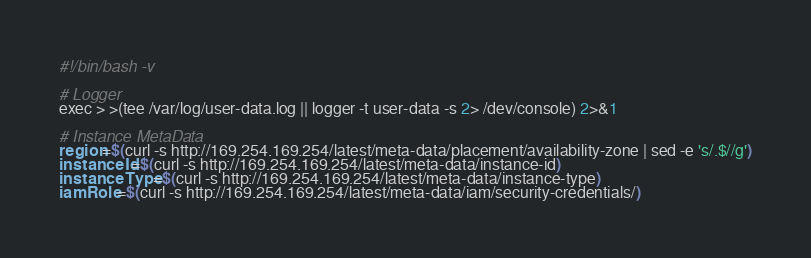Convert code to text. <code><loc_0><loc_0><loc_500><loc_500><_Bash_>#!/bin/bash -v

# Logger
exec > >(tee /var/log/user-data.log || logger -t user-data -s 2> /dev/console) 2>&1

# Instance MetaData
region=$(curl -s http://169.254.169.254/latest/meta-data/placement/availability-zone | sed -e 's/.$//g')
instanceId=$(curl -s http://169.254.169.254/latest/meta-data/instance-id)
instanceType=$(curl -s http://169.254.169.254/latest/meta-data/instance-type)
iamRole=$(curl -s http://169.254.169.254/latest/meta-data/iam/security-credentials/)</code> 